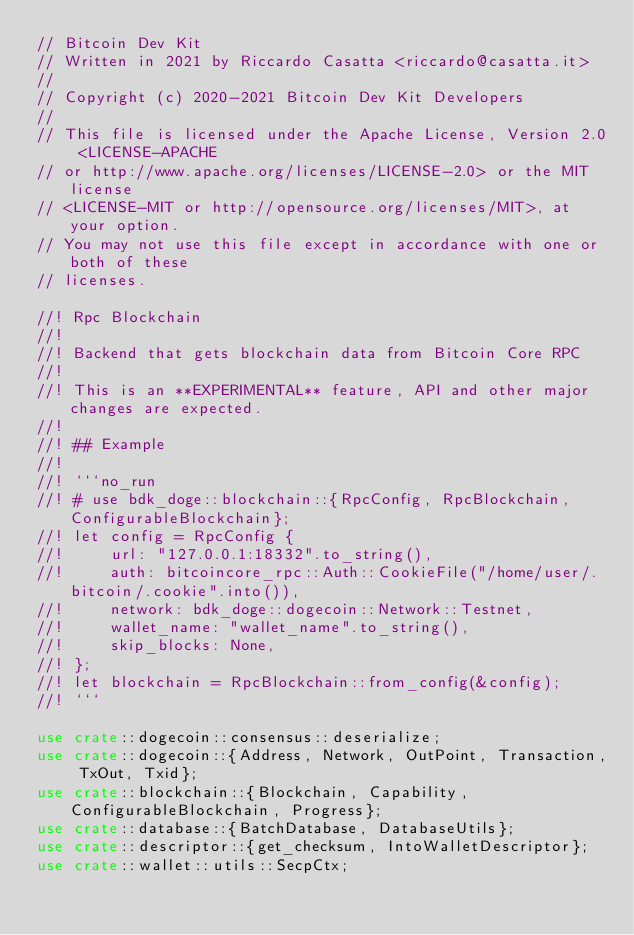Convert code to text. <code><loc_0><loc_0><loc_500><loc_500><_Rust_>// Bitcoin Dev Kit
// Written in 2021 by Riccardo Casatta <riccardo@casatta.it>
//
// Copyright (c) 2020-2021 Bitcoin Dev Kit Developers
//
// This file is licensed under the Apache License, Version 2.0 <LICENSE-APACHE
// or http://www.apache.org/licenses/LICENSE-2.0> or the MIT license
// <LICENSE-MIT or http://opensource.org/licenses/MIT>, at your option.
// You may not use this file except in accordance with one or both of these
// licenses.

//! Rpc Blockchain
//!
//! Backend that gets blockchain data from Bitcoin Core RPC
//!
//! This is an **EXPERIMENTAL** feature, API and other major changes are expected.
//!
//! ## Example
//!
//! ```no_run
//! # use bdk_doge::blockchain::{RpcConfig, RpcBlockchain, ConfigurableBlockchain};
//! let config = RpcConfig {
//!     url: "127.0.0.1:18332".to_string(),
//!     auth: bitcoincore_rpc::Auth::CookieFile("/home/user/.bitcoin/.cookie".into()),
//!     network: bdk_doge::dogecoin::Network::Testnet,
//!     wallet_name: "wallet_name".to_string(),
//!     skip_blocks: None,
//! };
//! let blockchain = RpcBlockchain::from_config(&config);
//! ```

use crate::dogecoin::consensus::deserialize;
use crate::dogecoin::{Address, Network, OutPoint, Transaction, TxOut, Txid};
use crate::blockchain::{Blockchain, Capability, ConfigurableBlockchain, Progress};
use crate::database::{BatchDatabase, DatabaseUtils};
use crate::descriptor::{get_checksum, IntoWalletDescriptor};
use crate::wallet::utils::SecpCtx;</code> 